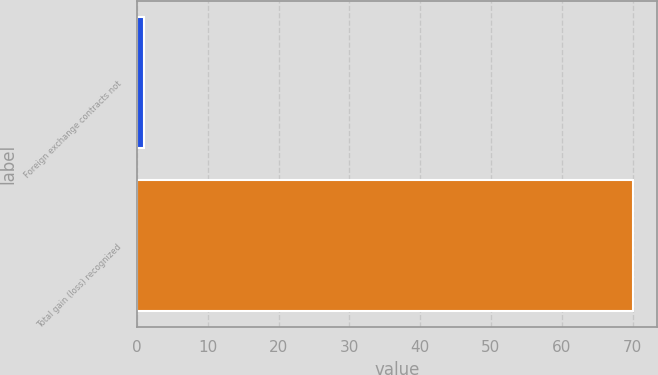<chart> <loc_0><loc_0><loc_500><loc_500><bar_chart><fcel>Foreign exchange contracts not<fcel>Total gain (loss) recognized<nl><fcel>1<fcel>70<nl></chart> 